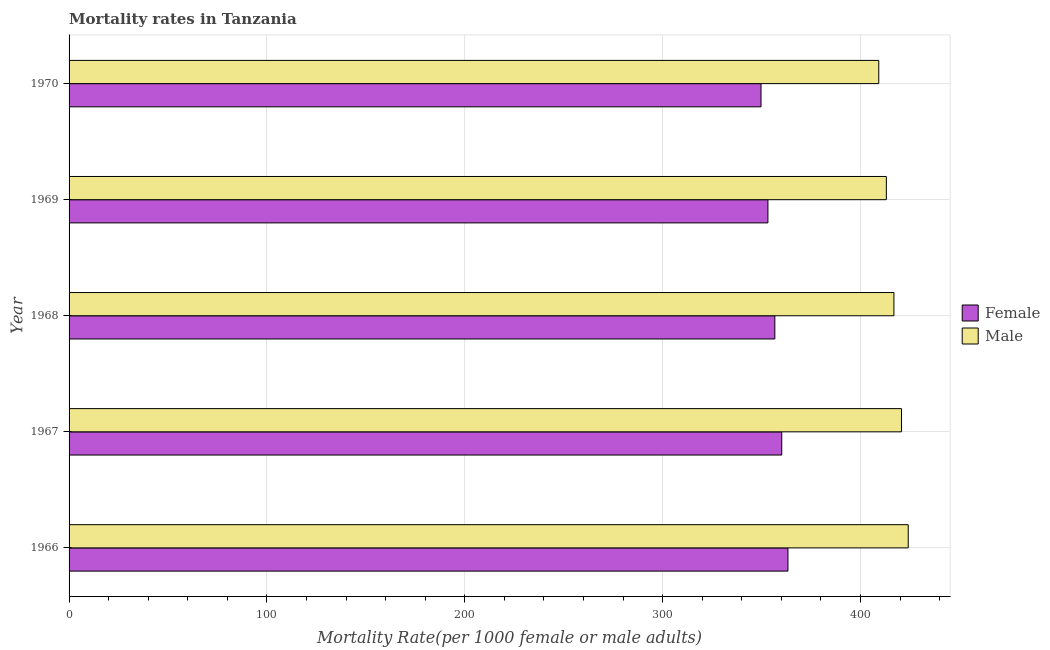How many different coloured bars are there?
Provide a short and direct response. 2. How many groups of bars are there?
Offer a terse response. 5. Are the number of bars on each tick of the Y-axis equal?
Provide a short and direct response. Yes. What is the label of the 4th group of bars from the top?
Offer a terse response. 1967. What is the male mortality rate in 1967?
Offer a very short reply. 420.72. Across all years, what is the maximum male mortality rate?
Keep it short and to the point. 424.13. Across all years, what is the minimum female mortality rate?
Ensure brevity in your answer.  349.72. In which year was the male mortality rate maximum?
Provide a succinct answer. 1966. In which year was the female mortality rate minimum?
Ensure brevity in your answer.  1970. What is the total male mortality rate in the graph?
Provide a short and direct response. 2084.03. What is the difference between the female mortality rate in 1967 and that in 1970?
Offer a very short reply. 10.49. What is the difference between the female mortality rate in 1966 and the male mortality rate in 1968?
Keep it short and to the point. -53.55. What is the average male mortality rate per year?
Make the answer very short. 416.81. In the year 1967, what is the difference between the female mortality rate and male mortality rate?
Give a very brief answer. -60.52. In how many years, is the female mortality rate greater than 260 ?
Provide a short and direct response. 5. What is the ratio of the female mortality rate in 1967 to that in 1968?
Keep it short and to the point. 1.01. What is the difference between the highest and the second highest female mortality rate?
Your answer should be compact. 3.13. What is the difference between the highest and the lowest female mortality rate?
Offer a very short reply. 13.62. What does the 1st bar from the top in 1966 represents?
Make the answer very short. Male. What does the 2nd bar from the bottom in 1970 represents?
Give a very brief answer. Male. Are all the bars in the graph horizontal?
Provide a short and direct response. Yes. How many years are there in the graph?
Offer a very short reply. 5. Are the values on the major ticks of X-axis written in scientific E-notation?
Keep it short and to the point. No. Does the graph contain grids?
Ensure brevity in your answer.  Yes. What is the title of the graph?
Your answer should be compact. Mortality rates in Tanzania. What is the label or title of the X-axis?
Provide a succinct answer. Mortality Rate(per 1000 female or male adults). What is the label or title of the Y-axis?
Keep it short and to the point. Year. What is the Mortality Rate(per 1000 female or male adults) in Female in 1966?
Give a very brief answer. 363.34. What is the Mortality Rate(per 1000 female or male adults) in Male in 1966?
Your answer should be very brief. 424.13. What is the Mortality Rate(per 1000 female or male adults) in Female in 1967?
Offer a terse response. 360.2. What is the Mortality Rate(per 1000 female or male adults) of Male in 1967?
Ensure brevity in your answer.  420.72. What is the Mortality Rate(per 1000 female or male adults) of Female in 1968?
Give a very brief answer. 356.71. What is the Mortality Rate(per 1000 female or male adults) in Male in 1968?
Ensure brevity in your answer.  416.89. What is the Mortality Rate(per 1000 female or male adults) of Female in 1969?
Ensure brevity in your answer.  353.21. What is the Mortality Rate(per 1000 female or male adults) of Male in 1969?
Provide a succinct answer. 413.06. What is the Mortality Rate(per 1000 female or male adults) in Female in 1970?
Ensure brevity in your answer.  349.72. What is the Mortality Rate(per 1000 female or male adults) in Male in 1970?
Keep it short and to the point. 409.23. Across all years, what is the maximum Mortality Rate(per 1000 female or male adults) of Female?
Offer a terse response. 363.34. Across all years, what is the maximum Mortality Rate(per 1000 female or male adults) of Male?
Your response must be concise. 424.13. Across all years, what is the minimum Mortality Rate(per 1000 female or male adults) of Female?
Provide a short and direct response. 349.72. Across all years, what is the minimum Mortality Rate(per 1000 female or male adults) of Male?
Your answer should be very brief. 409.23. What is the total Mortality Rate(per 1000 female or male adults) in Female in the graph?
Ensure brevity in your answer.  1783.18. What is the total Mortality Rate(per 1000 female or male adults) of Male in the graph?
Offer a very short reply. 2084.03. What is the difference between the Mortality Rate(per 1000 female or male adults) in Female in 1966 and that in 1967?
Offer a very short reply. 3.13. What is the difference between the Mortality Rate(per 1000 female or male adults) in Male in 1966 and that in 1967?
Ensure brevity in your answer.  3.41. What is the difference between the Mortality Rate(per 1000 female or male adults) in Female in 1966 and that in 1968?
Make the answer very short. 6.63. What is the difference between the Mortality Rate(per 1000 female or male adults) of Male in 1966 and that in 1968?
Give a very brief answer. 7.24. What is the difference between the Mortality Rate(per 1000 female or male adults) of Female in 1966 and that in 1969?
Give a very brief answer. 10.12. What is the difference between the Mortality Rate(per 1000 female or male adults) of Male in 1966 and that in 1969?
Provide a short and direct response. 11.07. What is the difference between the Mortality Rate(per 1000 female or male adults) of Female in 1966 and that in 1970?
Your answer should be very brief. 13.62. What is the difference between the Mortality Rate(per 1000 female or male adults) of Male in 1966 and that in 1970?
Your response must be concise. 14.9. What is the difference between the Mortality Rate(per 1000 female or male adults) of Female in 1967 and that in 1968?
Ensure brevity in your answer.  3.5. What is the difference between the Mortality Rate(per 1000 female or male adults) of Male in 1967 and that in 1968?
Your answer should be very brief. 3.83. What is the difference between the Mortality Rate(per 1000 female or male adults) in Female in 1967 and that in 1969?
Give a very brief answer. 6.99. What is the difference between the Mortality Rate(per 1000 female or male adults) in Male in 1967 and that in 1969?
Your answer should be compact. 7.66. What is the difference between the Mortality Rate(per 1000 female or male adults) of Female in 1967 and that in 1970?
Keep it short and to the point. 10.49. What is the difference between the Mortality Rate(per 1000 female or male adults) in Male in 1967 and that in 1970?
Your response must be concise. 11.49. What is the difference between the Mortality Rate(per 1000 female or male adults) of Female in 1968 and that in 1969?
Provide a succinct answer. 3.5. What is the difference between the Mortality Rate(per 1000 female or male adults) of Male in 1968 and that in 1969?
Offer a very short reply. 3.83. What is the difference between the Mortality Rate(per 1000 female or male adults) in Female in 1968 and that in 1970?
Give a very brief answer. 6.99. What is the difference between the Mortality Rate(per 1000 female or male adults) of Male in 1968 and that in 1970?
Keep it short and to the point. 7.66. What is the difference between the Mortality Rate(per 1000 female or male adults) of Female in 1969 and that in 1970?
Keep it short and to the point. 3.5. What is the difference between the Mortality Rate(per 1000 female or male adults) of Male in 1969 and that in 1970?
Provide a short and direct response. 3.83. What is the difference between the Mortality Rate(per 1000 female or male adults) in Female in 1966 and the Mortality Rate(per 1000 female or male adults) in Male in 1967?
Your answer should be very brief. -57.38. What is the difference between the Mortality Rate(per 1000 female or male adults) in Female in 1966 and the Mortality Rate(per 1000 female or male adults) in Male in 1968?
Your answer should be compact. -53.55. What is the difference between the Mortality Rate(per 1000 female or male adults) in Female in 1966 and the Mortality Rate(per 1000 female or male adults) in Male in 1969?
Provide a short and direct response. -49.73. What is the difference between the Mortality Rate(per 1000 female or male adults) in Female in 1966 and the Mortality Rate(per 1000 female or male adults) in Male in 1970?
Provide a short and direct response. -45.9. What is the difference between the Mortality Rate(per 1000 female or male adults) of Female in 1967 and the Mortality Rate(per 1000 female or male adults) of Male in 1968?
Provide a succinct answer. -56.69. What is the difference between the Mortality Rate(per 1000 female or male adults) in Female in 1967 and the Mortality Rate(per 1000 female or male adults) in Male in 1969?
Your response must be concise. -52.86. What is the difference between the Mortality Rate(per 1000 female or male adults) of Female in 1967 and the Mortality Rate(per 1000 female or male adults) of Male in 1970?
Ensure brevity in your answer.  -49.03. What is the difference between the Mortality Rate(per 1000 female or male adults) in Female in 1968 and the Mortality Rate(per 1000 female or male adults) in Male in 1969?
Provide a short and direct response. -56.35. What is the difference between the Mortality Rate(per 1000 female or male adults) in Female in 1968 and the Mortality Rate(per 1000 female or male adults) in Male in 1970?
Keep it short and to the point. -52.52. What is the difference between the Mortality Rate(per 1000 female or male adults) in Female in 1969 and the Mortality Rate(per 1000 female or male adults) in Male in 1970?
Your answer should be compact. -56.02. What is the average Mortality Rate(per 1000 female or male adults) of Female per year?
Keep it short and to the point. 356.64. What is the average Mortality Rate(per 1000 female or male adults) of Male per year?
Your answer should be very brief. 416.81. In the year 1966, what is the difference between the Mortality Rate(per 1000 female or male adults) in Female and Mortality Rate(per 1000 female or male adults) in Male?
Offer a terse response. -60.79. In the year 1967, what is the difference between the Mortality Rate(per 1000 female or male adults) of Female and Mortality Rate(per 1000 female or male adults) of Male?
Give a very brief answer. -60.52. In the year 1968, what is the difference between the Mortality Rate(per 1000 female or male adults) of Female and Mortality Rate(per 1000 female or male adults) of Male?
Offer a terse response. -60.18. In the year 1969, what is the difference between the Mortality Rate(per 1000 female or male adults) of Female and Mortality Rate(per 1000 female or male adults) of Male?
Offer a terse response. -59.85. In the year 1970, what is the difference between the Mortality Rate(per 1000 female or male adults) in Female and Mortality Rate(per 1000 female or male adults) in Male?
Offer a very short reply. -59.51. What is the ratio of the Mortality Rate(per 1000 female or male adults) in Female in 1966 to that in 1967?
Your answer should be very brief. 1.01. What is the ratio of the Mortality Rate(per 1000 female or male adults) in Female in 1966 to that in 1968?
Give a very brief answer. 1.02. What is the ratio of the Mortality Rate(per 1000 female or male adults) of Male in 1966 to that in 1968?
Ensure brevity in your answer.  1.02. What is the ratio of the Mortality Rate(per 1000 female or male adults) of Female in 1966 to that in 1969?
Your response must be concise. 1.03. What is the ratio of the Mortality Rate(per 1000 female or male adults) of Male in 1966 to that in 1969?
Make the answer very short. 1.03. What is the ratio of the Mortality Rate(per 1000 female or male adults) of Female in 1966 to that in 1970?
Ensure brevity in your answer.  1.04. What is the ratio of the Mortality Rate(per 1000 female or male adults) in Male in 1966 to that in 1970?
Offer a very short reply. 1.04. What is the ratio of the Mortality Rate(per 1000 female or male adults) in Female in 1967 to that in 1968?
Make the answer very short. 1.01. What is the ratio of the Mortality Rate(per 1000 female or male adults) of Male in 1967 to that in 1968?
Your answer should be compact. 1.01. What is the ratio of the Mortality Rate(per 1000 female or male adults) of Female in 1967 to that in 1969?
Keep it short and to the point. 1.02. What is the ratio of the Mortality Rate(per 1000 female or male adults) in Male in 1967 to that in 1969?
Offer a terse response. 1.02. What is the ratio of the Mortality Rate(per 1000 female or male adults) in Male in 1967 to that in 1970?
Your answer should be compact. 1.03. What is the ratio of the Mortality Rate(per 1000 female or male adults) in Female in 1968 to that in 1969?
Provide a short and direct response. 1.01. What is the ratio of the Mortality Rate(per 1000 female or male adults) of Male in 1968 to that in 1969?
Make the answer very short. 1.01. What is the ratio of the Mortality Rate(per 1000 female or male adults) in Female in 1968 to that in 1970?
Provide a short and direct response. 1.02. What is the ratio of the Mortality Rate(per 1000 female or male adults) in Male in 1968 to that in 1970?
Give a very brief answer. 1.02. What is the ratio of the Mortality Rate(per 1000 female or male adults) in Male in 1969 to that in 1970?
Make the answer very short. 1.01. What is the difference between the highest and the second highest Mortality Rate(per 1000 female or male adults) in Female?
Your answer should be very brief. 3.13. What is the difference between the highest and the second highest Mortality Rate(per 1000 female or male adults) in Male?
Offer a terse response. 3.41. What is the difference between the highest and the lowest Mortality Rate(per 1000 female or male adults) of Female?
Your answer should be very brief. 13.62. What is the difference between the highest and the lowest Mortality Rate(per 1000 female or male adults) in Male?
Your answer should be compact. 14.9. 